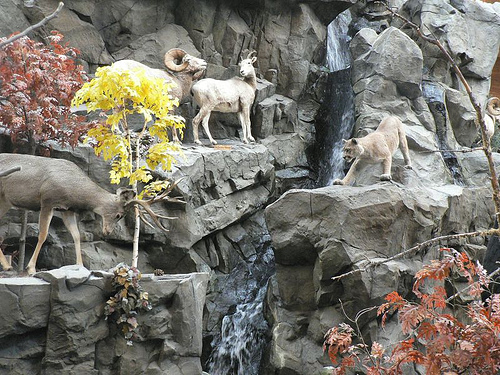<image>
Is the goat in front of the tree? No. The goat is not in front of the tree. The spatial positioning shows a different relationship between these objects. 